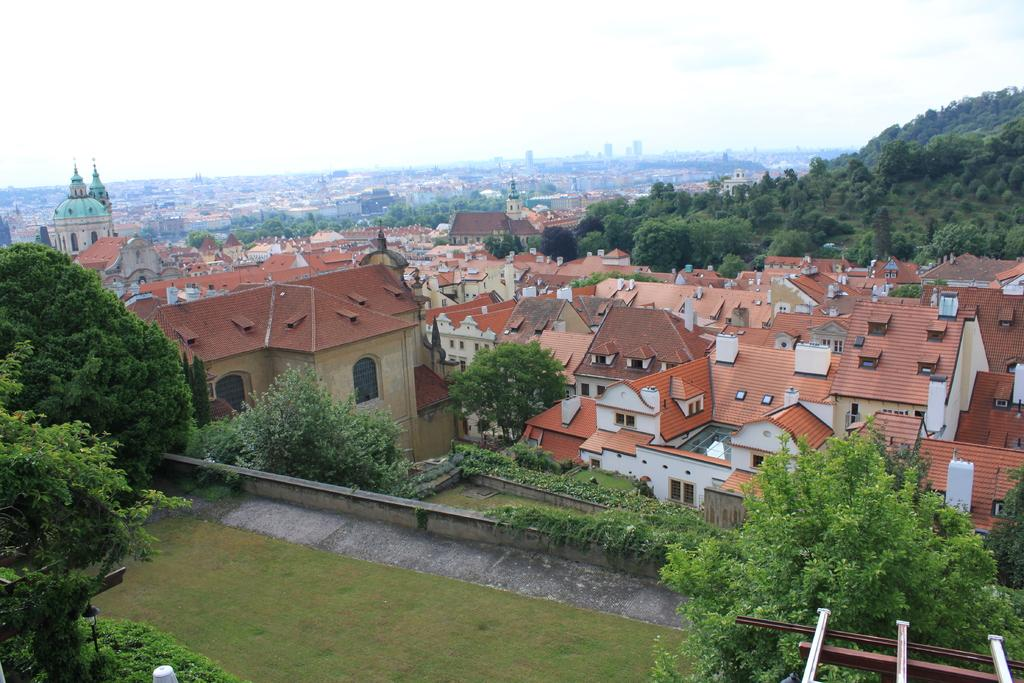What type of view is provided in the image? The image is a top view. What type of vegetation can be seen in the image? There are trees and grass in the image. What type of structures are present in the image? There are houses in the image. Where are the trees located in relation to the hills in the image? The trees are on hills in the image. What is visible in the background of the image? The sky is visible in the background of the image. How many kites are being flown by the fowl in the image? There are no kites or fowl present in the image. 